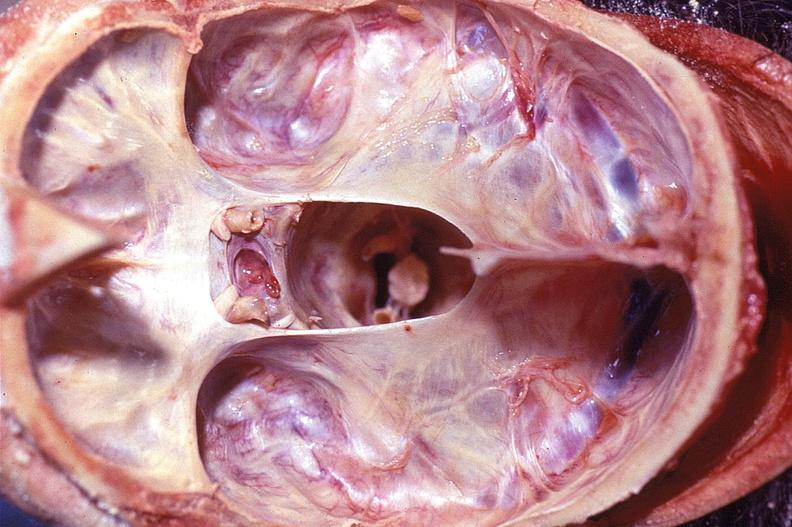what does this image show?
Answer the question using a single word or phrase. Calvarium 